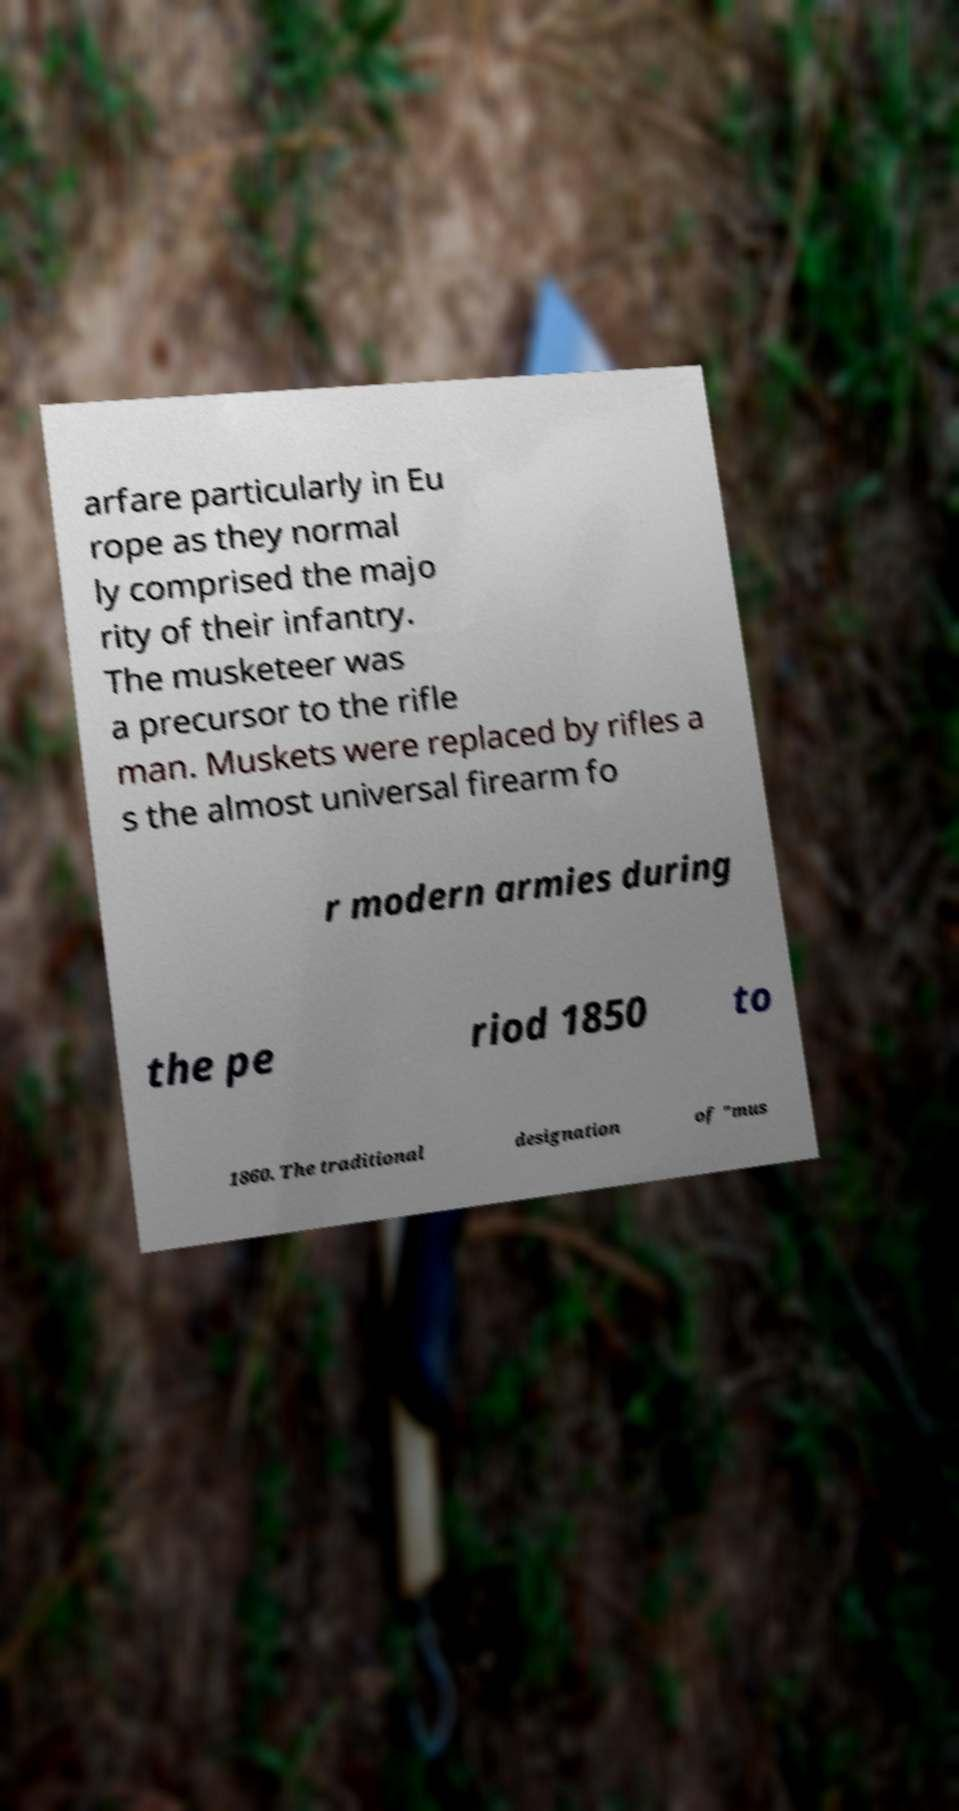Can you accurately transcribe the text from the provided image for me? arfare particularly in Eu rope as they normal ly comprised the majo rity of their infantry. The musketeer was a precursor to the rifle man. Muskets were replaced by rifles a s the almost universal firearm fo r modern armies during the pe riod 1850 to 1860. The traditional designation of "mus 